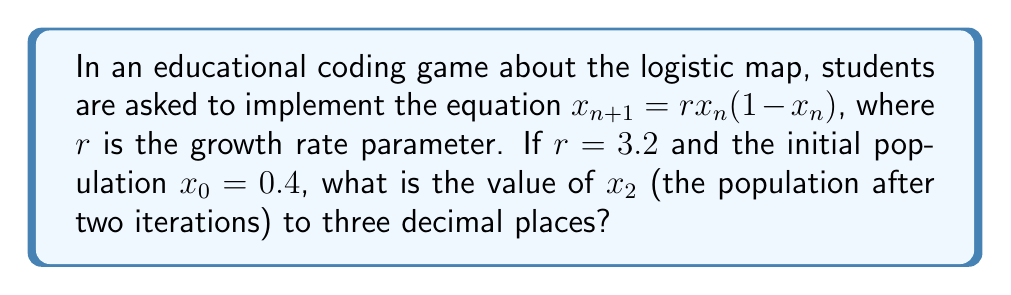Could you help me with this problem? Let's approach this step-by-step:

1) The logistic map equation is given by:
   $$x_{n+1} = rx_n(1-x_n)$$

2) We're given that $r = 3.2$ and $x_0 = 0.4$

3) First, let's calculate $x_1$:
   $$x_1 = 3.2 \cdot 0.4 \cdot (1-0.4)$$
   $$x_1 = 3.2 \cdot 0.4 \cdot 0.6$$
   $$x_1 = 0.768$$

4) Now, we use this value of $x_1$ to calculate $x_2$:
   $$x_2 = 3.2 \cdot 0.768 \cdot (1-0.768)$$
   $$x_2 = 3.2 \cdot 0.768 \cdot 0.232$$
   $$x_2 = 0.570163$$

5) Rounding to three decimal places:
   $$x_2 \approx 0.570$$

This process demonstrates how students can implement the logistic map equation in a programming environment, iterating through generations of a population.
Answer: 0.570 